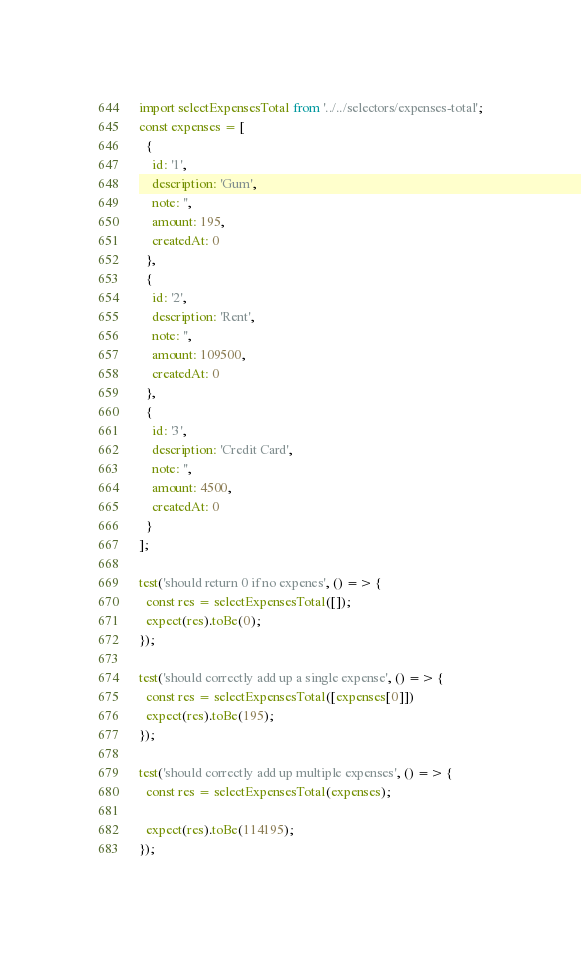Convert code to text. <code><loc_0><loc_0><loc_500><loc_500><_JavaScript_>import selectExpensesTotal from '../../selectors/expenses-total';
const expenses = [
  {
    id: '1',
    description: 'Gum',
    note: '',
    amount: 195,
    createdAt: 0
  },
  {
    id: '2',
    description: 'Rent',
    note: '',
    amount: 109500,
    createdAt: 0
  },
  {
    id: '3',
    description: 'Credit Card',
    note: '',
    amount: 4500,
    createdAt: 0
  }
]; 

test('should return 0 if no expenes', () => {
  const res = selectExpensesTotal([]);
  expect(res).toBe(0);
});

test('should correctly add up a single expense', () => {
  const res = selectExpensesTotal([expenses[0]])
  expect(res).toBe(195);
});

test('should correctly add up multiple expenses', () => {
  const res = selectExpensesTotal(expenses);
  
  expect(res).toBe(114195);
});</code> 